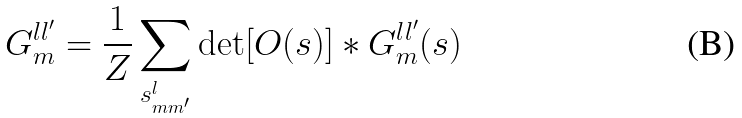Convert formula to latex. <formula><loc_0><loc_0><loc_500><loc_500>G _ { m } ^ { l l ^ { \prime } } = \frac { 1 } { Z } \sum _ { s _ { m m ^ { \prime } } ^ { l } } \det [ O ( s ) ] * G _ { m } ^ { l l ^ { \prime } } ( s )</formula> 